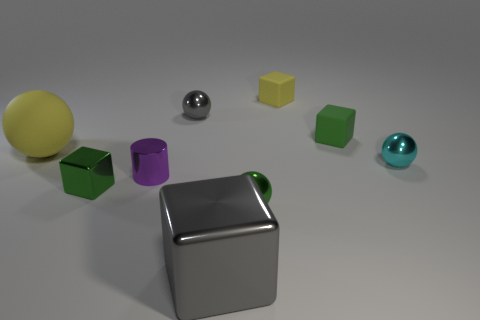Subtract all yellow spheres. How many spheres are left? 3 Subtract all cylinders. How many objects are left? 8 Subtract all yellow spheres. How many spheres are left? 3 Subtract all blue cubes. Subtract all blue balls. How many cubes are left? 4 Subtract all purple balls. How many yellow cylinders are left? 0 Subtract all rubber cylinders. Subtract all big gray shiny objects. How many objects are left? 8 Add 9 gray metallic cubes. How many gray metallic cubes are left? 10 Add 9 purple cylinders. How many purple cylinders exist? 10 Subtract 0 red cubes. How many objects are left? 9 Subtract 2 spheres. How many spheres are left? 2 